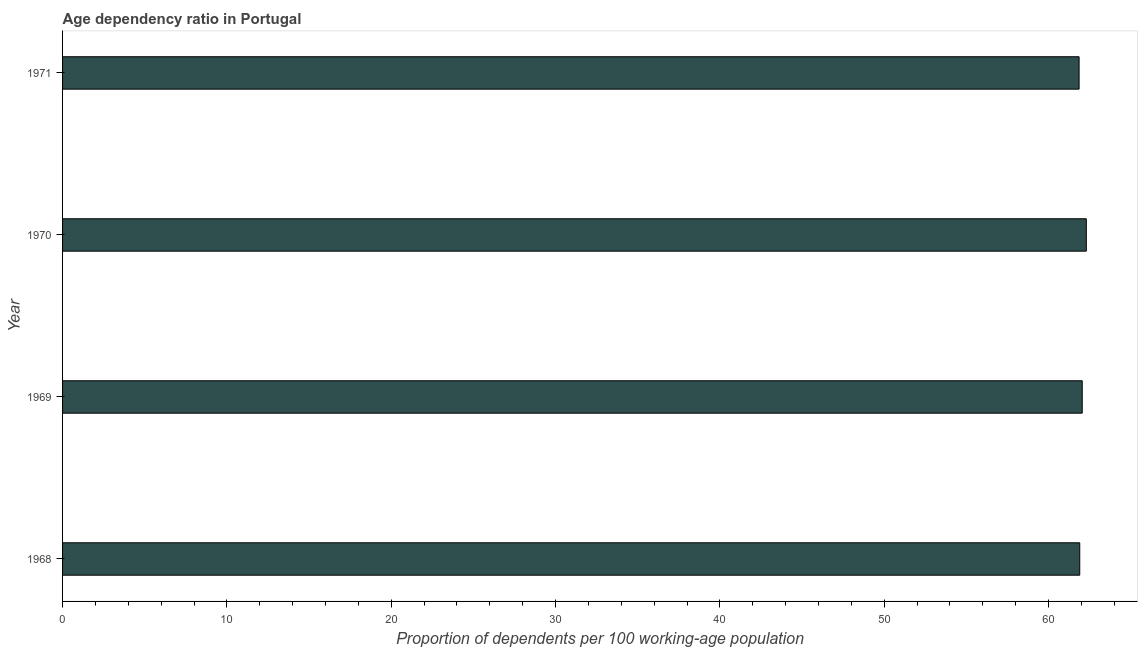Does the graph contain grids?
Make the answer very short. No. What is the title of the graph?
Your response must be concise. Age dependency ratio in Portugal. What is the label or title of the X-axis?
Offer a terse response. Proportion of dependents per 100 working-age population. What is the label or title of the Y-axis?
Your answer should be compact. Year. What is the age dependency ratio in 1971?
Keep it short and to the point. 61.86. Across all years, what is the maximum age dependency ratio?
Offer a terse response. 62.3. Across all years, what is the minimum age dependency ratio?
Your answer should be very brief. 61.86. What is the sum of the age dependency ratio?
Your response must be concise. 248.1. What is the difference between the age dependency ratio in 1968 and 1970?
Your answer should be very brief. -0.4. What is the average age dependency ratio per year?
Your response must be concise. 62.02. What is the median age dependency ratio?
Your response must be concise. 61.97. What is the ratio of the age dependency ratio in 1970 to that in 1971?
Offer a very short reply. 1.01. What is the difference between the highest and the second highest age dependency ratio?
Give a very brief answer. 0.25. What is the difference between the highest and the lowest age dependency ratio?
Keep it short and to the point. 0.44. How many bars are there?
Offer a very short reply. 4. Are all the bars in the graph horizontal?
Your answer should be compact. Yes. What is the Proportion of dependents per 100 working-age population in 1968?
Make the answer very short. 61.9. What is the Proportion of dependents per 100 working-age population in 1969?
Your response must be concise. 62.05. What is the Proportion of dependents per 100 working-age population of 1970?
Offer a terse response. 62.3. What is the Proportion of dependents per 100 working-age population of 1971?
Provide a succinct answer. 61.86. What is the difference between the Proportion of dependents per 100 working-age population in 1968 and 1969?
Ensure brevity in your answer.  -0.15. What is the difference between the Proportion of dependents per 100 working-age population in 1968 and 1970?
Offer a terse response. -0.4. What is the difference between the Proportion of dependents per 100 working-age population in 1968 and 1971?
Provide a succinct answer. 0.04. What is the difference between the Proportion of dependents per 100 working-age population in 1969 and 1970?
Ensure brevity in your answer.  -0.25. What is the difference between the Proportion of dependents per 100 working-age population in 1969 and 1971?
Make the answer very short. 0.19. What is the difference between the Proportion of dependents per 100 working-age population in 1970 and 1971?
Offer a terse response. 0.44. What is the ratio of the Proportion of dependents per 100 working-age population in 1968 to that in 1969?
Provide a short and direct response. 1. What is the ratio of the Proportion of dependents per 100 working-age population in 1968 to that in 1970?
Ensure brevity in your answer.  0.99. What is the ratio of the Proportion of dependents per 100 working-age population in 1969 to that in 1970?
Keep it short and to the point. 1. What is the ratio of the Proportion of dependents per 100 working-age population in 1970 to that in 1971?
Your answer should be very brief. 1.01. 